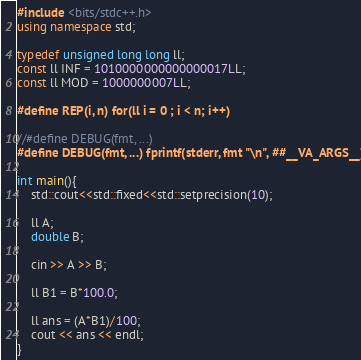<code> <loc_0><loc_0><loc_500><loc_500><_C++_>#include <bits/stdc++.h>
using namespace std;

typedef unsigned long long ll;
const ll INF = 1010000000000000017LL;
const ll MOD = 1000000007LL;

#define REP(i, n) for(ll i = 0 ; i < n; i++)

//#define DEBUG(fmt, ...)
#define DEBUG(fmt, ...) fprintf(stderr, fmt "\n", ##__VA_ARGS__)

int main(){
    std::cout<<std::fixed<<std::setprecision(10);

    ll A;
    double B;

    cin >> A >> B;

    ll B1 = B*100.0;

    ll ans = (A*B1)/100;
    cout << ans << endl;
}
</code> 